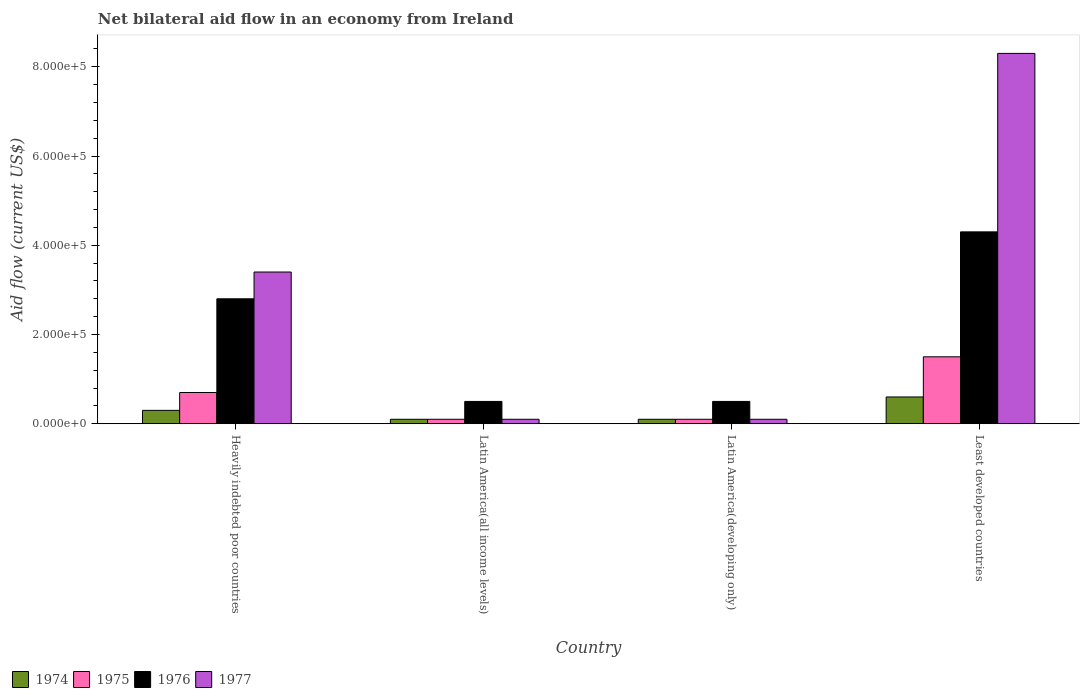How many different coloured bars are there?
Give a very brief answer. 4. How many groups of bars are there?
Your answer should be very brief. 4. Are the number of bars per tick equal to the number of legend labels?
Your response must be concise. Yes. How many bars are there on the 1st tick from the left?
Your response must be concise. 4. How many bars are there on the 4th tick from the right?
Provide a succinct answer. 4. What is the label of the 4th group of bars from the left?
Make the answer very short. Least developed countries. Across all countries, what is the maximum net bilateral aid flow in 1976?
Keep it short and to the point. 4.30e+05. In which country was the net bilateral aid flow in 1976 maximum?
Your response must be concise. Least developed countries. In which country was the net bilateral aid flow in 1974 minimum?
Give a very brief answer. Latin America(all income levels). What is the total net bilateral aid flow in 1977 in the graph?
Provide a short and direct response. 1.19e+06. What is the difference between the net bilateral aid flow in 1975 in Latin America(all income levels) and the net bilateral aid flow in 1977 in Latin America(developing only)?
Keep it short and to the point. 0. What is the average net bilateral aid flow in 1974 per country?
Make the answer very short. 2.75e+04. What is the difference between the net bilateral aid flow of/in 1974 and net bilateral aid flow of/in 1975 in Least developed countries?
Provide a succinct answer. -9.00e+04. What is the ratio of the net bilateral aid flow in 1977 in Heavily indebted poor countries to that in Latin America(developing only)?
Provide a succinct answer. 34. Is the difference between the net bilateral aid flow in 1974 in Latin America(all income levels) and Least developed countries greater than the difference between the net bilateral aid flow in 1975 in Latin America(all income levels) and Least developed countries?
Your response must be concise. Yes. What is the difference between the highest and the second highest net bilateral aid flow in 1975?
Your response must be concise. 1.40e+05. Is it the case that in every country, the sum of the net bilateral aid flow in 1974 and net bilateral aid flow in 1975 is greater than the sum of net bilateral aid flow in 1977 and net bilateral aid flow in 1976?
Your response must be concise. No. What does the 1st bar from the left in Latin America(developing only) represents?
Your answer should be compact. 1974. What does the 2nd bar from the right in Latin America(developing only) represents?
Give a very brief answer. 1976. How many bars are there?
Make the answer very short. 16. Are all the bars in the graph horizontal?
Give a very brief answer. No. What is the difference between two consecutive major ticks on the Y-axis?
Make the answer very short. 2.00e+05. Are the values on the major ticks of Y-axis written in scientific E-notation?
Offer a terse response. Yes. Does the graph contain grids?
Your answer should be very brief. No. Where does the legend appear in the graph?
Your answer should be very brief. Bottom left. What is the title of the graph?
Your answer should be very brief. Net bilateral aid flow in an economy from Ireland. Does "1971" appear as one of the legend labels in the graph?
Offer a very short reply. No. What is the Aid flow (current US$) of 1974 in Heavily indebted poor countries?
Your response must be concise. 3.00e+04. What is the Aid flow (current US$) in 1977 in Heavily indebted poor countries?
Keep it short and to the point. 3.40e+05. What is the Aid flow (current US$) in 1975 in Latin America(all income levels)?
Make the answer very short. 10000. What is the Aid flow (current US$) of 1975 in Latin America(developing only)?
Keep it short and to the point. 10000. What is the Aid flow (current US$) of 1977 in Latin America(developing only)?
Offer a terse response. 10000. What is the Aid flow (current US$) in 1975 in Least developed countries?
Make the answer very short. 1.50e+05. What is the Aid flow (current US$) in 1976 in Least developed countries?
Offer a very short reply. 4.30e+05. What is the Aid flow (current US$) of 1977 in Least developed countries?
Provide a succinct answer. 8.30e+05. Across all countries, what is the maximum Aid flow (current US$) of 1975?
Ensure brevity in your answer.  1.50e+05. Across all countries, what is the maximum Aid flow (current US$) of 1977?
Your answer should be very brief. 8.30e+05. Across all countries, what is the minimum Aid flow (current US$) in 1974?
Your answer should be compact. 10000. Across all countries, what is the minimum Aid flow (current US$) in 1975?
Ensure brevity in your answer.  10000. Across all countries, what is the minimum Aid flow (current US$) in 1977?
Your answer should be compact. 10000. What is the total Aid flow (current US$) in 1975 in the graph?
Provide a succinct answer. 2.40e+05. What is the total Aid flow (current US$) in 1976 in the graph?
Give a very brief answer. 8.10e+05. What is the total Aid flow (current US$) of 1977 in the graph?
Make the answer very short. 1.19e+06. What is the difference between the Aid flow (current US$) in 1974 in Heavily indebted poor countries and that in Latin America(all income levels)?
Your answer should be compact. 2.00e+04. What is the difference between the Aid flow (current US$) in 1974 in Heavily indebted poor countries and that in Latin America(developing only)?
Provide a short and direct response. 2.00e+04. What is the difference between the Aid flow (current US$) of 1977 in Heavily indebted poor countries and that in Latin America(developing only)?
Your answer should be compact. 3.30e+05. What is the difference between the Aid flow (current US$) in 1974 in Heavily indebted poor countries and that in Least developed countries?
Your answer should be very brief. -3.00e+04. What is the difference between the Aid flow (current US$) of 1975 in Heavily indebted poor countries and that in Least developed countries?
Ensure brevity in your answer.  -8.00e+04. What is the difference between the Aid flow (current US$) in 1976 in Heavily indebted poor countries and that in Least developed countries?
Your response must be concise. -1.50e+05. What is the difference between the Aid flow (current US$) in 1977 in Heavily indebted poor countries and that in Least developed countries?
Your answer should be very brief. -4.90e+05. What is the difference between the Aid flow (current US$) of 1974 in Latin America(all income levels) and that in Latin America(developing only)?
Offer a terse response. 0. What is the difference between the Aid flow (current US$) of 1977 in Latin America(all income levels) and that in Latin America(developing only)?
Ensure brevity in your answer.  0. What is the difference between the Aid flow (current US$) of 1975 in Latin America(all income levels) and that in Least developed countries?
Provide a succinct answer. -1.40e+05. What is the difference between the Aid flow (current US$) in 1976 in Latin America(all income levels) and that in Least developed countries?
Make the answer very short. -3.80e+05. What is the difference between the Aid flow (current US$) of 1977 in Latin America(all income levels) and that in Least developed countries?
Offer a very short reply. -8.20e+05. What is the difference between the Aid flow (current US$) of 1974 in Latin America(developing only) and that in Least developed countries?
Offer a very short reply. -5.00e+04. What is the difference between the Aid flow (current US$) in 1975 in Latin America(developing only) and that in Least developed countries?
Provide a short and direct response. -1.40e+05. What is the difference between the Aid flow (current US$) in 1976 in Latin America(developing only) and that in Least developed countries?
Keep it short and to the point. -3.80e+05. What is the difference between the Aid flow (current US$) in 1977 in Latin America(developing only) and that in Least developed countries?
Offer a very short reply. -8.20e+05. What is the difference between the Aid flow (current US$) of 1974 in Heavily indebted poor countries and the Aid flow (current US$) of 1975 in Latin America(all income levels)?
Ensure brevity in your answer.  2.00e+04. What is the difference between the Aid flow (current US$) of 1974 in Heavily indebted poor countries and the Aid flow (current US$) of 1976 in Latin America(all income levels)?
Offer a very short reply. -2.00e+04. What is the difference between the Aid flow (current US$) of 1974 in Heavily indebted poor countries and the Aid flow (current US$) of 1976 in Latin America(developing only)?
Give a very brief answer. -2.00e+04. What is the difference between the Aid flow (current US$) of 1976 in Heavily indebted poor countries and the Aid flow (current US$) of 1977 in Latin America(developing only)?
Give a very brief answer. 2.70e+05. What is the difference between the Aid flow (current US$) of 1974 in Heavily indebted poor countries and the Aid flow (current US$) of 1976 in Least developed countries?
Keep it short and to the point. -4.00e+05. What is the difference between the Aid flow (current US$) in 1974 in Heavily indebted poor countries and the Aid flow (current US$) in 1977 in Least developed countries?
Make the answer very short. -8.00e+05. What is the difference between the Aid flow (current US$) in 1975 in Heavily indebted poor countries and the Aid flow (current US$) in 1976 in Least developed countries?
Your answer should be very brief. -3.60e+05. What is the difference between the Aid flow (current US$) of 1975 in Heavily indebted poor countries and the Aid flow (current US$) of 1977 in Least developed countries?
Give a very brief answer. -7.60e+05. What is the difference between the Aid flow (current US$) of 1976 in Heavily indebted poor countries and the Aid flow (current US$) of 1977 in Least developed countries?
Offer a very short reply. -5.50e+05. What is the difference between the Aid flow (current US$) in 1974 in Latin America(all income levels) and the Aid flow (current US$) in 1975 in Latin America(developing only)?
Your response must be concise. 0. What is the difference between the Aid flow (current US$) of 1975 in Latin America(all income levels) and the Aid flow (current US$) of 1977 in Latin America(developing only)?
Provide a short and direct response. 0. What is the difference between the Aid flow (current US$) in 1974 in Latin America(all income levels) and the Aid flow (current US$) in 1975 in Least developed countries?
Provide a succinct answer. -1.40e+05. What is the difference between the Aid flow (current US$) in 1974 in Latin America(all income levels) and the Aid flow (current US$) in 1976 in Least developed countries?
Your response must be concise. -4.20e+05. What is the difference between the Aid flow (current US$) of 1974 in Latin America(all income levels) and the Aid flow (current US$) of 1977 in Least developed countries?
Offer a terse response. -8.20e+05. What is the difference between the Aid flow (current US$) in 1975 in Latin America(all income levels) and the Aid flow (current US$) in 1976 in Least developed countries?
Provide a short and direct response. -4.20e+05. What is the difference between the Aid flow (current US$) in 1975 in Latin America(all income levels) and the Aid flow (current US$) in 1977 in Least developed countries?
Provide a short and direct response. -8.20e+05. What is the difference between the Aid flow (current US$) of 1976 in Latin America(all income levels) and the Aid flow (current US$) of 1977 in Least developed countries?
Provide a short and direct response. -7.80e+05. What is the difference between the Aid flow (current US$) in 1974 in Latin America(developing only) and the Aid flow (current US$) in 1975 in Least developed countries?
Provide a short and direct response. -1.40e+05. What is the difference between the Aid flow (current US$) in 1974 in Latin America(developing only) and the Aid flow (current US$) in 1976 in Least developed countries?
Ensure brevity in your answer.  -4.20e+05. What is the difference between the Aid flow (current US$) in 1974 in Latin America(developing only) and the Aid flow (current US$) in 1977 in Least developed countries?
Provide a short and direct response. -8.20e+05. What is the difference between the Aid flow (current US$) in 1975 in Latin America(developing only) and the Aid flow (current US$) in 1976 in Least developed countries?
Offer a very short reply. -4.20e+05. What is the difference between the Aid flow (current US$) in 1975 in Latin America(developing only) and the Aid flow (current US$) in 1977 in Least developed countries?
Your answer should be compact. -8.20e+05. What is the difference between the Aid flow (current US$) in 1976 in Latin America(developing only) and the Aid flow (current US$) in 1977 in Least developed countries?
Ensure brevity in your answer.  -7.80e+05. What is the average Aid flow (current US$) of 1974 per country?
Provide a succinct answer. 2.75e+04. What is the average Aid flow (current US$) of 1976 per country?
Ensure brevity in your answer.  2.02e+05. What is the average Aid flow (current US$) in 1977 per country?
Give a very brief answer. 2.98e+05. What is the difference between the Aid flow (current US$) in 1974 and Aid flow (current US$) in 1975 in Heavily indebted poor countries?
Ensure brevity in your answer.  -4.00e+04. What is the difference between the Aid flow (current US$) in 1974 and Aid flow (current US$) in 1977 in Heavily indebted poor countries?
Give a very brief answer. -3.10e+05. What is the difference between the Aid flow (current US$) of 1975 and Aid flow (current US$) of 1976 in Heavily indebted poor countries?
Your answer should be compact. -2.10e+05. What is the difference between the Aid flow (current US$) of 1975 and Aid flow (current US$) of 1977 in Heavily indebted poor countries?
Provide a succinct answer. -2.70e+05. What is the difference between the Aid flow (current US$) in 1976 and Aid flow (current US$) in 1977 in Heavily indebted poor countries?
Offer a terse response. -6.00e+04. What is the difference between the Aid flow (current US$) of 1974 and Aid flow (current US$) of 1976 in Latin America(all income levels)?
Your answer should be very brief. -4.00e+04. What is the difference between the Aid flow (current US$) in 1975 and Aid flow (current US$) in 1976 in Latin America(all income levels)?
Provide a short and direct response. -4.00e+04. What is the difference between the Aid flow (current US$) of 1976 and Aid flow (current US$) of 1977 in Latin America(all income levels)?
Offer a terse response. 4.00e+04. What is the difference between the Aid flow (current US$) of 1974 and Aid flow (current US$) of 1975 in Latin America(developing only)?
Ensure brevity in your answer.  0. What is the difference between the Aid flow (current US$) in 1975 and Aid flow (current US$) in 1976 in Latin America(developing only)?
Offer a very short reply. -4.00e+04. What is the difference between the Aid flow (current US$) of 1975 and Aid flow (current US$) of 1977 in Latin America(developing only)?
Offer a very short reply. 0. What is the difference between the Aid flow (current US$) of 1974 and Aid flow (current US$) of 1976 in Least developed countries?
Provide a short and direct response. -3.70e+05. What is the difference between the Aid flow (current US$) of 1974 and Aid flow (current US$) of 1977 in Least developed countries?
Offer a very short reply. -7.70e+05. What is the difference between the Aid flow (current US$) of 1975 and Aid flow (current US$) of 1976 in Least developed countries?
Offer a very short reply. -2.80e+05. What is the difference between the Aid flow (current US$) of 1975 and Aid flow (current US$) of 1977 in Least developed countries?
Keep it short and to the point. -6.80e+05. What is the difference between the Aid flow (current US$) in 1976 and Aid flow (current US$) in 1977 in Least developed countries?
Your response must be concise. -4.00e+05. What is the ratio of the Aid flow (current US$) of 1976 in Heavily indebted poor countries to that in Latin America(all income levels)?
Ensure brevity in your answer.  5.6. What is the ratio of the Aid flow (current US$) in 1977 in Heavily indebted poor countries to that in Latin America(all income levels)?
Offer a very short reply. 34. What is the ratio of the Aid flow (current US$) in 1975 in Heavily indebted poor countries to that in Latin America(developing only)?
Make the answer very short. 7. What is the ratio of the Aid flow (current US$) of 1976 in Heavily indebted poor countries to that in Latin America(developing only)?
Ensure brevity in your answer.  5.6. What is the ratio of the Aid flow (current US$) of 1974 in Heavily indebted poor countries to that in Least developed countries?
Provide a succinct answer. 0.5. What is the ratio of the Aid flow (current US$) in 1975 in Heavily indebted poor countries to that in Least developed countries?
Ensure brevity in your answer.  0.47. What is the ratio of the Aid flow (current US$) in 1976 in Heavily indebted poor countries to that in Least developed countries?
Ensure brevity in your answer.  0.65. What is the ratio of the Aid flow (current US$) of 1977 in Heavily indebted poor countries to that in Least developed countries?
Ensure brevity in your answer.  0.41. What is the ratio of the Aid flow (current US$) in 1974 in Latin America(all income levels) to that in Latin America(developing only)?
Give a very brief answer. 1. What is the ratio of the Aid flow (current US$) in 1975 in Latin America(all income levels) to that in Latin America(developing only)?
Your answer should be very brief. 1. What is the ratio of the Aid flow (current US$) of 1975 in Latin America(all income levels) to that in Least developed countries?
Make the answer very short. 0.07. What is the ratio of the Aid flow (current US$) of 1976 in Latin America(all income levels) to that in Least developed countries?
Provide a short and direct response. 0.12. What is the ratio of the Aid flow (current US$) of 1977 in Latin America(all income levels) to that in Least developed countries?
Offer a very short reply. 0.01. What is the ratio of the Aid flow (current US$) in 1975 in Latin America(developing only) to that in Least developed countries?
Offer a terse response. 0.07. What is the ratio of the Aid flow (current US$) of 1976 in Latin America(developing only) to that in Least developed countries?
Ensure brevity in your answer.  0.12. What is the ratio of the Aid flow (current US$) in 1977 in Latin America(developing only) to that in Least developed countries?
Your answer should be compact. 0.01. What is the difference between the highest and the second highest Aid flow (current US$) in 1974?
Your response must be concise. 3.00e+04. What is the difference between the highest and the second highest Aid flow (current US$) of 1976?
Provide a succinct answer. 1.50e+05. What is the difference between the highest and the second highest Aid flow (current US$) of 1977?
Provide a succinct answer. 4.90e+05. What is the difference between the highest and the lowest Aid flow (current US$) of 1974?
Your response must be concise. 5.00e+04. What is the difference between the highest and the lowest Aid flow (current US$) in 1975?
Your answer should be compact. 1.40e+05. What is the difference between the highest and the lowest Aid flow (current US$) in 1976?
Offer a very short reply. 3.80e+05. What is the difference between the highest and the lowest Aid flow (current US$) in 1977?
Your answer should be compact. 8.20e+05. 